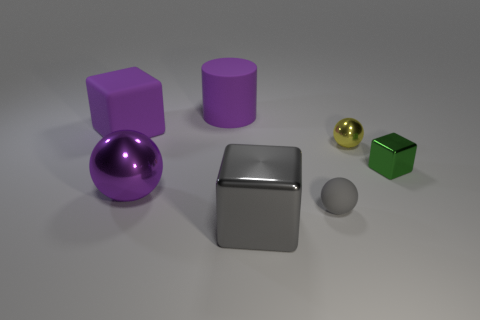Subtract 1 balls. How many balls are left? 2 Subtract all metallic blocks. How many blocks are left? 1 Add 1 gray objects. How many objects exist? 8 Subtract all cylinders. How many objects are left? 6 Subtract all big brown spheres. Subtract all tiny yellow metal objects. How many objects are left? 6 Add 1 tiny cubes. How many tiny cubes are left? 2 Add 6 balls. How many balls exist? 9 Subtract 0 green spheres. How many objects are left? 7 